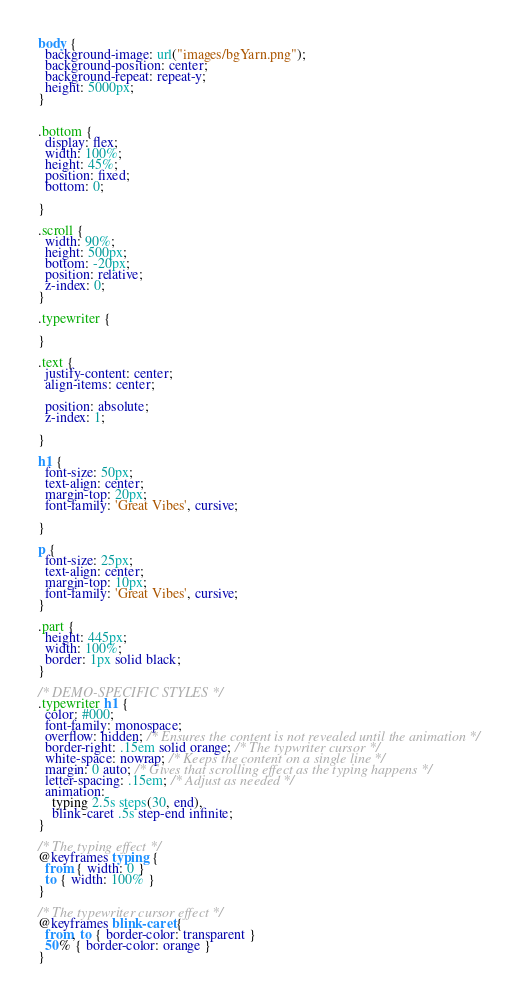<code> <loc_0><loc_0><loc_500><loc_500><_CSS_>
body {
  background-image: url("images/bgYarn.png");
  background-position: center;
  background-repeat: repeat-y;
  height: 5000px;
}


.bottom {
  display: flex;
  width: 100%;
  height: 45%;
  position: fixed;
  bottom: 0;

}

.scroll {
  width: 90%;
  height: 500px;
  bottom: -20px;
  position: relative;
  z-index: 0;
}

.typewriter {

}

.text {
  justify-content: center;
  align-items: center;

  position: absolute;
  z-index: 1;

}

h1 {
  font-size: 50px;
  text-align: center;
  margin-top: 20px;
  font-family: 'Great Vibes', cursive;

}

p {
  font-size: 25px;
  text-align: center;
  margin-top: 10px;
  font-family: 'Great Vibes', cursive;
}

.part {
  height: 445px;
  width: 100%;
  border: 1px solid black;
}

/* DEMO-SPECIFIC STYLES */
.typewriter h1 {
  color: #000;
  font-family: monospace;
  overflow: hidden; /* Ensures the content is not revealed until the animation */
  border-right: .15em solid orange; /* The typwriter cursor */
  white-space: nowrap; /* Keeps the content on a single line */
  margin: 0 auto; /* Gives that scrolling effect as the typing happens */
  letter-spacing: .15em; /* Adjust as needed */
  animation:
    typing 2.5s steps(30, end),
    blink-caret .5s step-end infinite;
}

/* The typing effect */
@keyframes typing {
  from { width: 0 }
  to { width: 100% }
}

/* The typewriter cursor effect */
@keyframes blink-caret {
  from, to { border-color: transparent }
  50% { border-color: orange }
}
</code> 